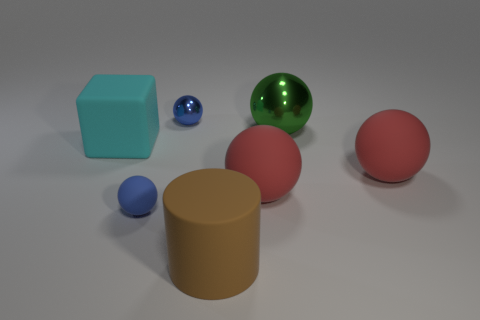Is there anything else that has the same shape as the cyan matte object?
Provide a short and direct response. No. How many other rubber objects are the same size as the brown rubber object?
Your response must be concise. 3. The other small thing that is the same color as the tiny metallic object is what shape?
Your answer should be compact. Sphere. What is the material of the big green object?
Your response must be concise. Metal. How big is the metallic sphere that is left of the matte cylinder?
Make the answer very short. Small. What number of small metallic objects have the same shape as the big cyan rubber thing?
Provide a short and direct response. 0. There is a brown object that is made of the same material as the block; what is its shape?
Your response must be concise. Cylinder. How many green things are big metal objects or tiny shiny balls?
Make the answer very short. 1. There is a big green sphere; are there any matte things to the left of it?
Provide a short and direct response. Yes. There is a metal thing to the left of the brown matte cylinder; does it have the same shape as the large thing to the left of the brown matte cylinder?
Keep it short and to the point. No. 